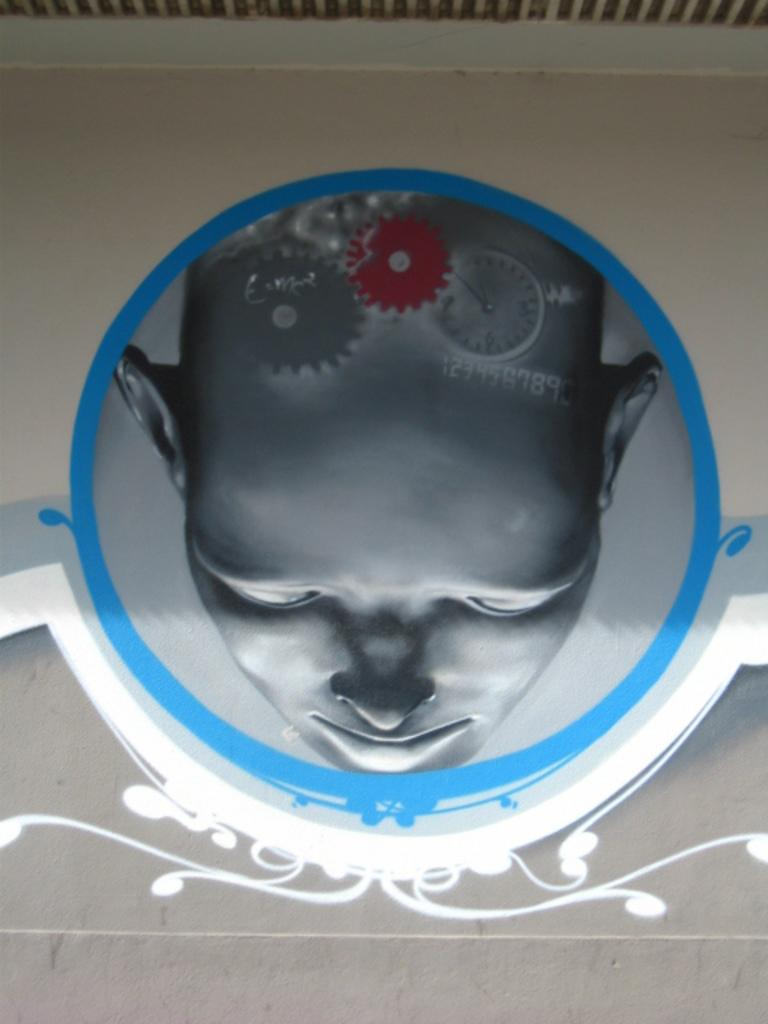What is depicted in the image? There is a painting of a person in the image. Where is the painting located? The painting is on a wall. What else can be seen in the painting besides the person? There are other things in the painting. What type of popcorn is being served in the image? There is no popcorn present in the image; it features a painting of a person on a wall. How many cents are visible in the image? There are no cents visible in the image. 